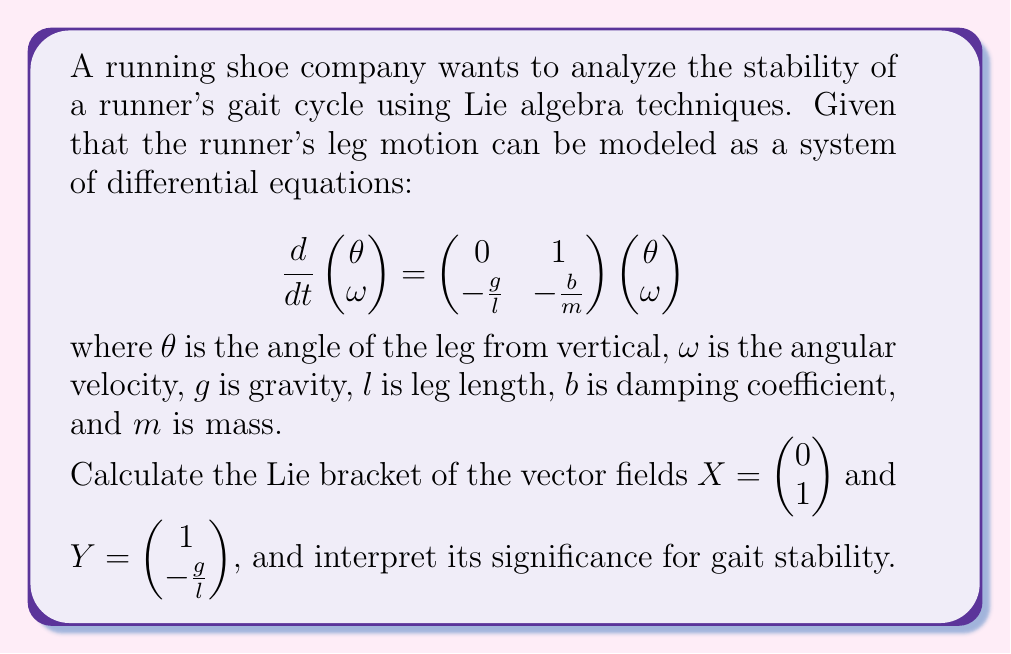Can you solve this math problem? To solve this problem, we'll follow these steps:

1) Recall that for vector fields $X = f(x)\frac{\partial}{\partial x} + g(x)\frac{\partial}{\partial y}$ and $Y = h(x)\frac{\partial}{\partial x} + k(x)\frac{\partial}{\partial y}$, the Lie bracket $[X,Y]$ is given by:

   $$[X,Y] = \left(f\frac{\partial h}{\partial x} + g\frac{\partial h}{\partial y} - h\frac{\partial f}{\partial x} - k\frac{\partial f}{\partial y}\right)\frac{\partial}{\partial x} + \left(f\frac{\partial k}{\partial x} + g\frac{\partial k}{\partial y} - h\frac{\partial g}{\partial x} - k\frac{\partial g}{\partial y}\right)\frac{\partial}{\partial y}$$

2) In our case:
   $X = 0\frac{\partial}{\partial \theta} + 1\frac{\partial}{\partial \omega}$
   $Y = 1\frac{\partial}{\partial \theta} + (-\frac{g}{l})\frac{\partial}{\partial \omega}$

3) Calculating the partial derivatives:
   $\frac{\partial f}{\partial \theta} = \frac{\partial f}{\partial \omega} = 0$
   $\frac{\partial g}{\partial \theta} = \frac{\partial g}{\partial \omega} = 0$
   $\frac{\partial h}{\partial \theta} = \frac{\partial h}{\partial \omega} = 0$
   $\frac{\partial k}{\partial \theta} = \frac{\partial k}{\partial \omega} = 0$

4) Substituting into the Lie bracket formula:

   $$[X,Y] = (0 \cdot 0 + 1 \cdot 0 - 1 \cdot 0 - (-\frac{g}{l}) \cdot 0)\frac{\partial}{\partial \theta} + (0 \cdot 0 + 1 \cdot 0 - 1 \cdot 0 - (-\frac{g}{l}) \cdot 0)\frac{\partial}{\partial \omega}$$

5) Simplifying:

   $$[X,Y] = 0\frac{\partial}{\partial \theta} + 0\frac{\partial}{\partial \omega} = \begin{pmatrix} 0 \\ 0 \end{pmatrix}$$

6) Interpretation: The zero result of the Lie bracket indicates that the vector fields $X$ and $Y$ commute. In the context of gait stability, this suggests that the effects of these two components of the runner's leg motion (represented by $X$ and $Y$) are independent and do not interfere with each other. This independence contributes to the overall stability of the gait cycle, as changes in one aspect of the motion do not unpredictably affect the other.
Answer: The Lie bracket $[X,Y] = \begin{pmatrix} 0 \\ 0 \end{pmatrix}$, indicating that the vector fields commute and contribute to gait stability through their independent effects on the runner's leg motion. 